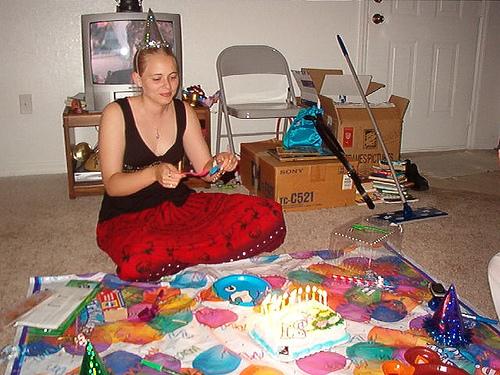What kind of celebration is this?
Be succinct. Birthday. How many party hats are in the image?
Be succinct. 3. Does the hat sparkle?
Write a very short answer. Yes. 